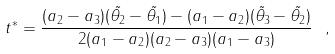<formula> <loc_0><loc_0><loc_500><loc_500>t ^ { * } = \frac { ( a _ { 2 } - a _ { 3 } ) ( \tilde { \theta _ { 2 } } - \tilde { \theta _ { 1 } } ) - ( a _ { 1 } - a _ { 2 } ) ( \tilde { \theta _ { 3 } } - \tilde { \theta _ { 2 } } ) } { 2 ( a _ { 1 } - a _ { 2 } ) ( a _ { 2 } - a _ { 3 } ) ( a _ { 1 } - a _ { 3 } ) } \ ,</formula> 